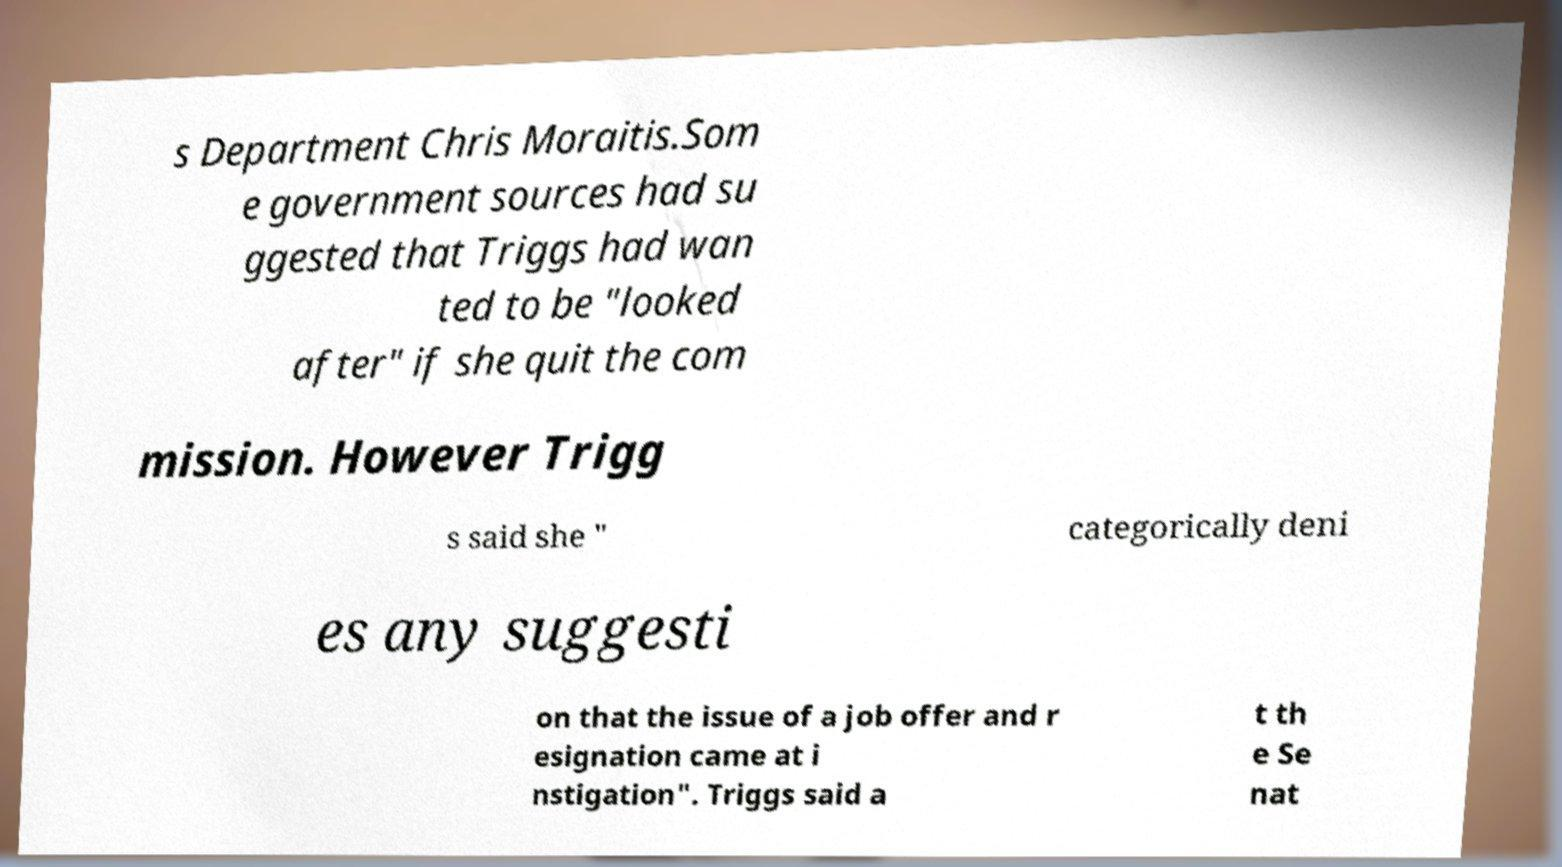Can you accurately transcribe the text from the provided image for me? s Department Chris Moraitis.Som e government sources had su ggested that Triggs had wan ted to be "looked after" if she quit the com mission. However Trigg s said she " categorically deni es any suggesti on that the issue of a job offer and r esignation came at i nstigation". Triggs said a t th e Se nat 